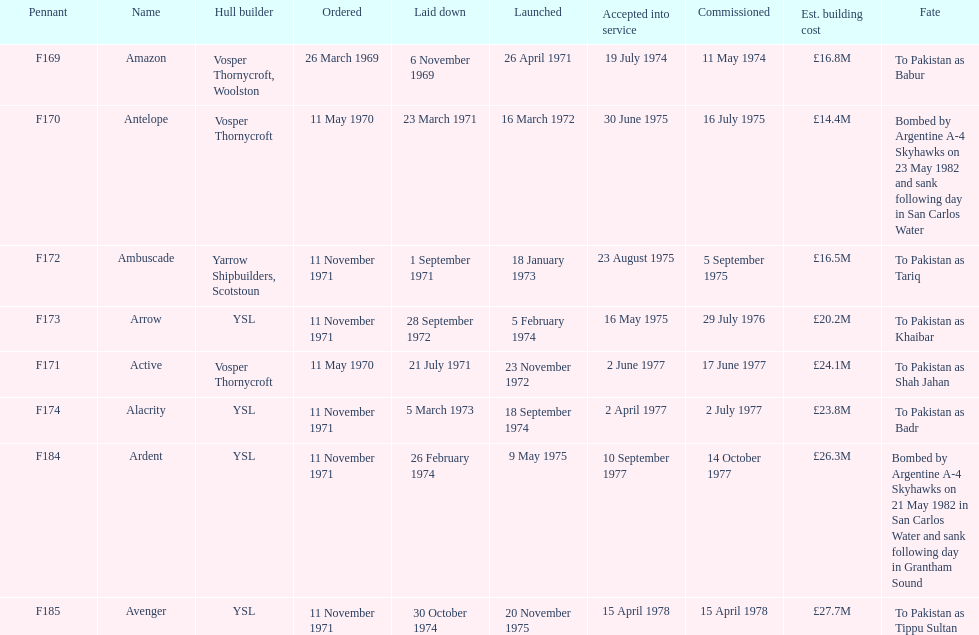What is the name of the ship listed after ardent? Avenger. Parse the full table. {'header': ['Pennant', 'Name', 'Hull builder', 'Ordered', 'Laid down', 'Launched', 'Accepted into service', 'Commissioned', 'Est. building cost', 'Fate'], 'rows': [['F169', 'Amazon', 'Vosper Thornycroft, Woolston', '26 March 1969', '6 November 1969', '26 April 1971', '19 July 1974', '11 May 1974', '£16.8M', 'To Pakistan as Babur'], ['F170', 'Antelope', 'Vosper Thornycroft', '11 May 1970', '23 March 1971', '16 March 1972', '30 June 1975', '16 July 1975', '£14.4M', 'Bombed by Argentine A-4 Skyhawks on 23 May 1982 and sank following day in San Carlos Water'], ['F172', 'Ambuscade', 'Yarrow Shipbuilders, Scotstoun', '11 November 1971', '1 September 1971', '18 January 1973', '23 August 1975', '5 September 1975', '£16.5M', 'To Pakistan as Tariq'], ['F173', 'Arrow', 'YSL', '11 November 1971', '28 September 1972', '5 February 1974', '16 May 1975', '29 July 1976', '£20.2M', 'To Pakistan as Khaibar'], ['F171', 'Active', 'Vosper Thornycroft', '11 May 1970', '21 July 1971', '23 November 1972', '2 June 1977', '17 June 1977', '£24.1M', 'To Pakistan as Shah Jahan'], ['F174', 'Alacrity', 'YSL', '11 November 1971', '5 March 1973', '18 September 1974', '2 April 1977', '2 July 1977', '£23.8M', 'To Pakistan as Badr'], ['F184', 'Ardent', 'YSL', '11 November 1971', '26 February 1974', '9 May 1975', '10 September 1977', '14 October 1977', '£26.3M', 'Bombed by Argentine A-4 Skyhawks on 21 May 1982 in San Carlos Water and sank following day in Grantham Sound'], ['F185', 'Avenger', 'YSL', '11 November 1971', '30 October 1974', '20 November 1975', '15 April 1978', '15 April 1978', '£27.7M', 'To Pakistan as Tippu Sultan']]} 